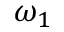Convert formula to latex. <formula><loc_0><loc_0><loc_500><loc_500>\omega _ { 1 }</formula> 